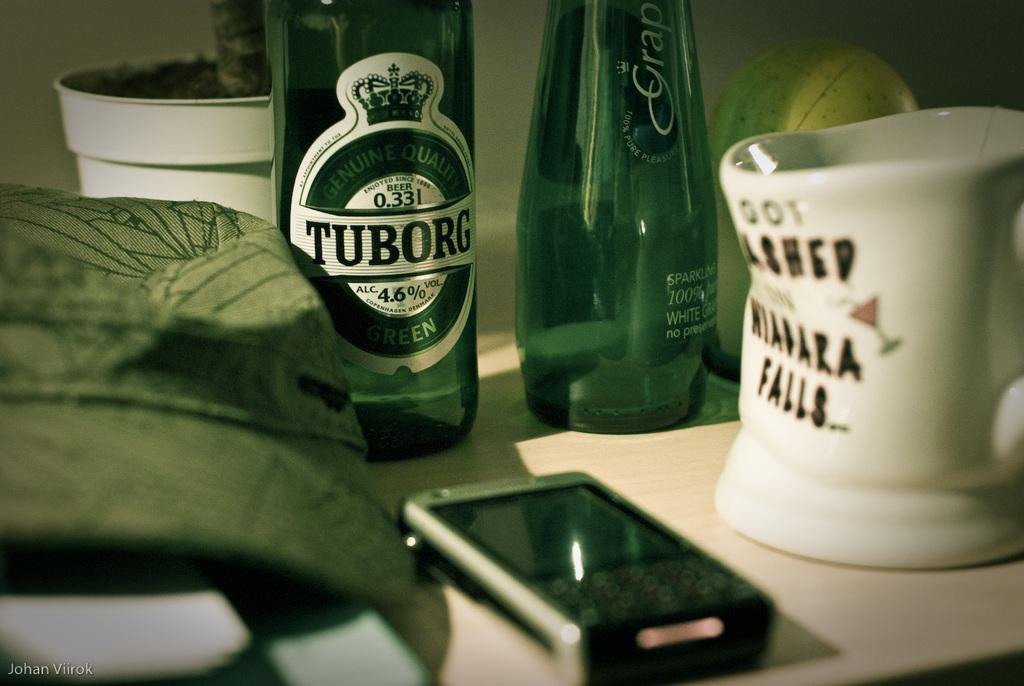<image>
Render a clear and concise summary of the photo. A phone, bottle of Turborg beer, and a Niagra falls coffee mug that appears to have melted. 